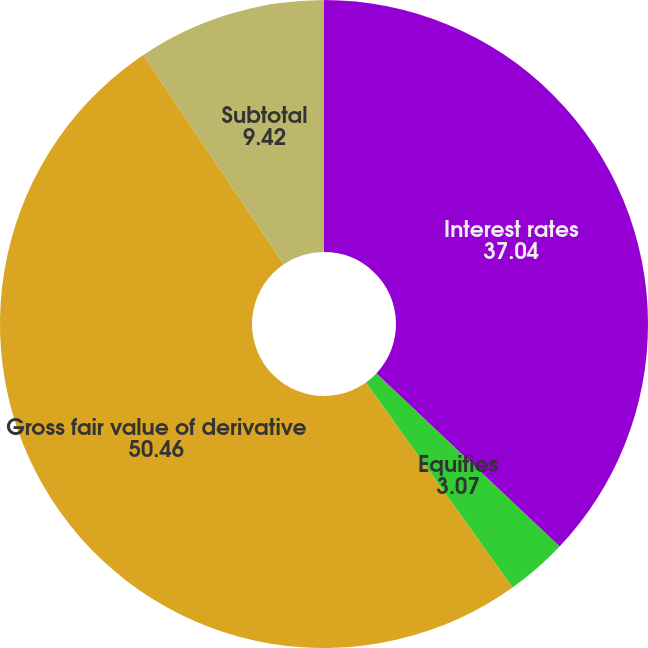<chart> <loc_0><loc_0><loc_500><loc_500><pie_chart><fcel>Interest rates<fcel>Equities<fcel>Gross fair value of derivative<fcel>Subtotal<nl><fcel>37.04%<fcel>3.07%<fcel>50.46%<fcel>9.42%<nl></chart> 